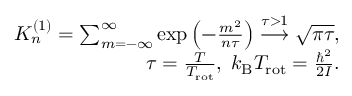Convert formula to latex. <formula><loc_0><loc_0><loc_500><loc_500>\begin{array} { r } { K _ { n } ^ { ( 1 ) } = \sum _ { m = - \infty } ^ { \infty } \exp \left ( - \frac { m ^ { 2 } } { n \tau } \right ) \overset { \tau > 1 } { \longrightarrow } \sqrt { \pi \tau } , } \\ { \tau = \frac { T } { T _ { r o t } } , \, k _ { B } T _ { r o t } = \frac { \hbar { ^ } { 2 } } { 2 I } . } \end{array}</formula> 